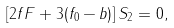Convert formula to latex. <formula><loc_0><loc_0><loc_500><loc_500>\left [ 2 f F + 3 ( f _ { 0 } - b ) \right ] S _ { 2 } = 0 ,</formula> 